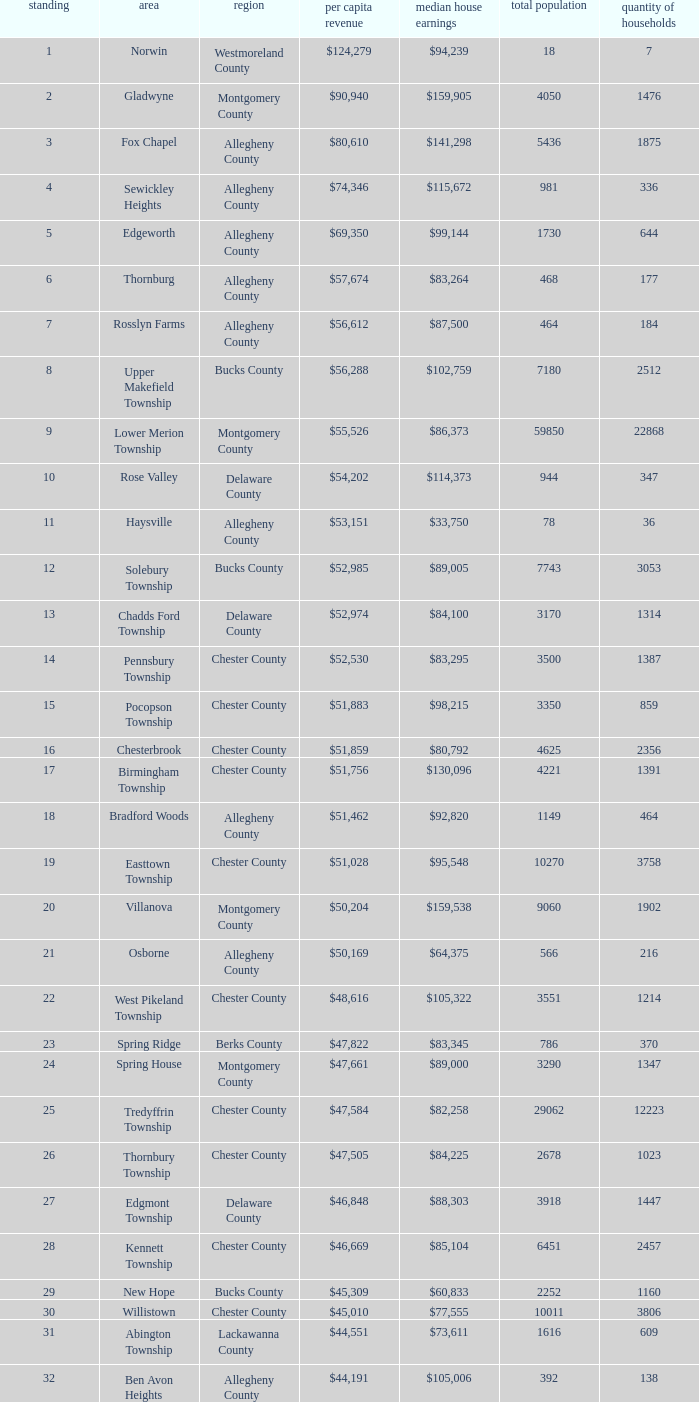What is the median household income for Woodside? $121,151. 